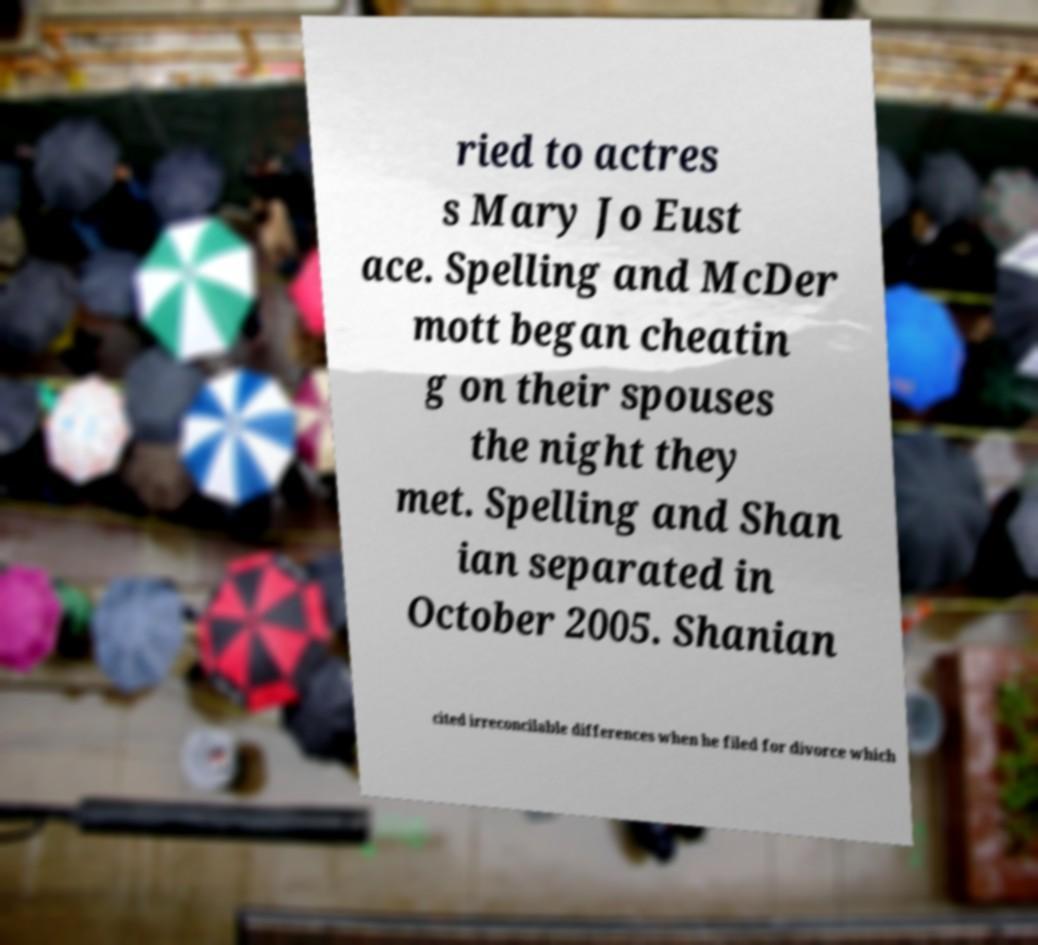Can you read and provide the text displayed in the image?This photo seems to have some interesting text. Can you extract and type it out for me? ried to actres s Mary Jo Eust ace. Spelling and McDer mott began cheatin g on their spouses the night they met. Spelling and Shan ian separated in October 2005. Shanian cited irreconcilable differences when he filed for divorce which 